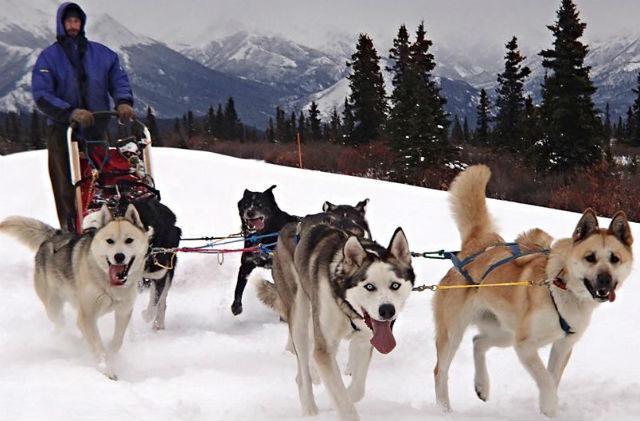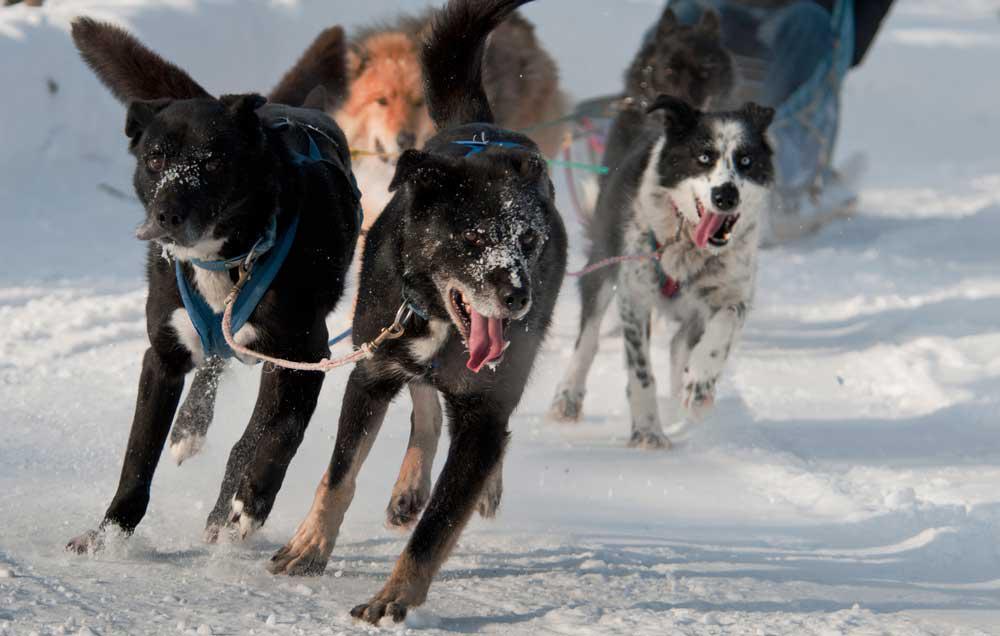The first image is the image on the left, the second image is the image on the right. For the images shown, is this caption "Both images in the pair show sled dogs attached to a sled." true? Answer yes or no. Yes. 